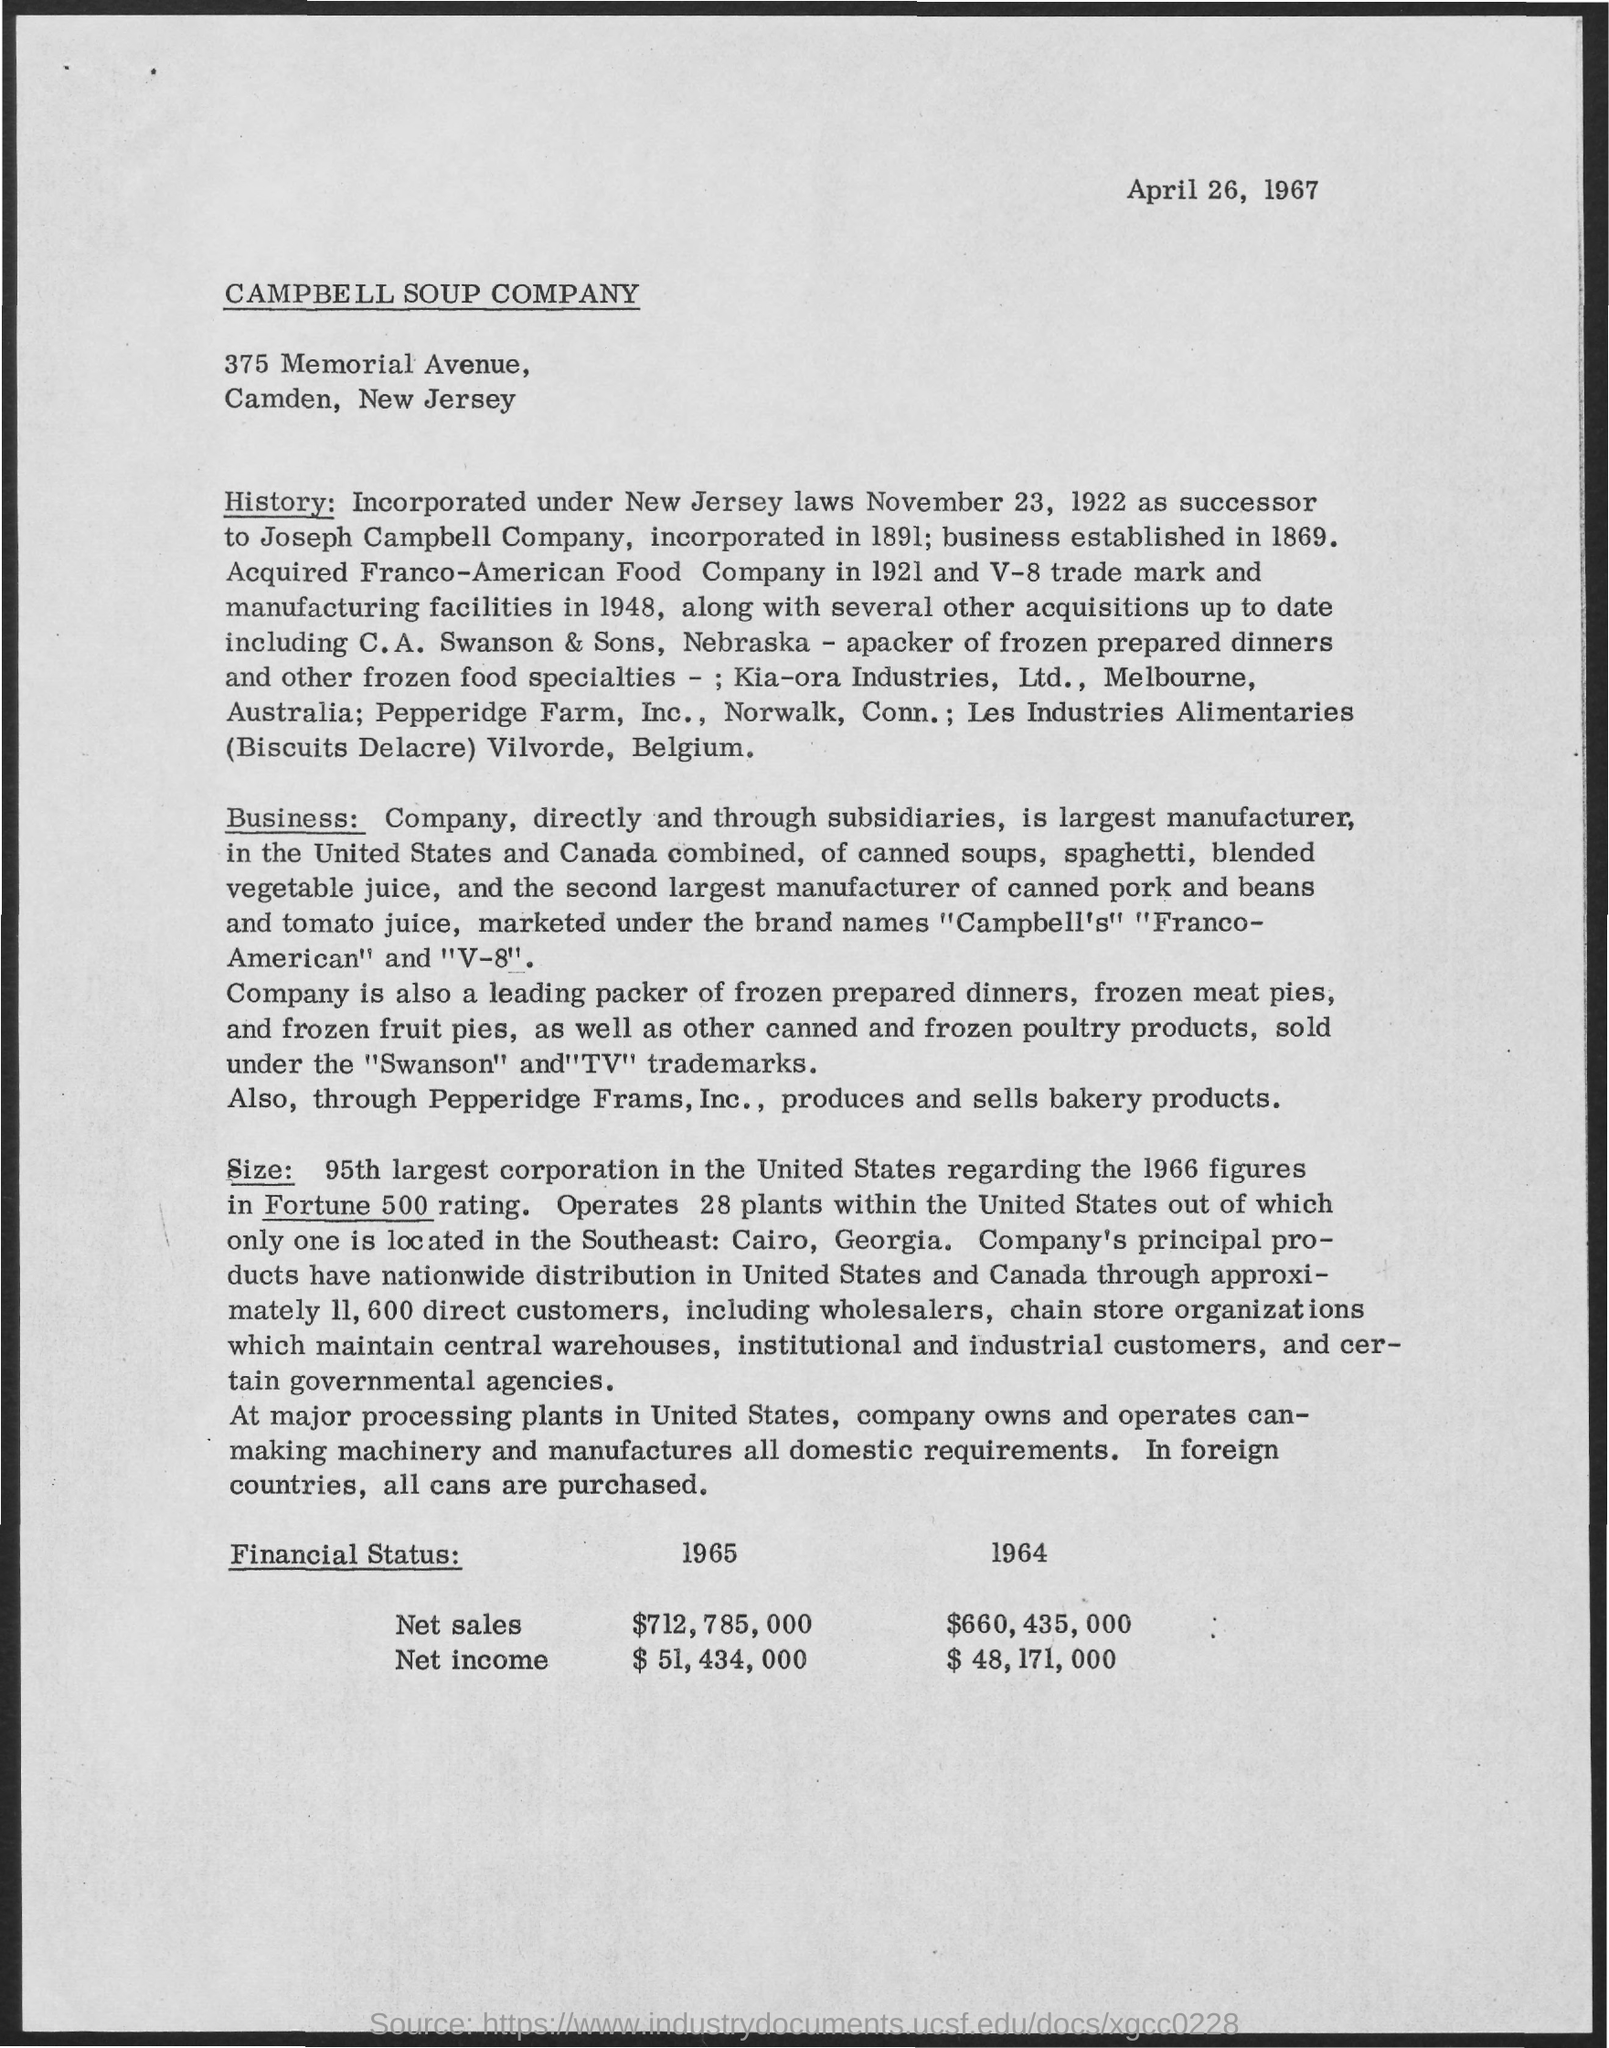Draw attention to some important aspects in this diagram. The date mentioned in the header of the document is April 26, 1967. In 1964, the net sales of Campbell Soup Company were $660,435,000. In the year 1965, the net sales of Campbell Soup Company were $712,785,000. The net income of Campbell Soup Company for the year 1965 was $51,434,000. Campbell Soup Company's net income for the year 1964 was $48,171,000. 